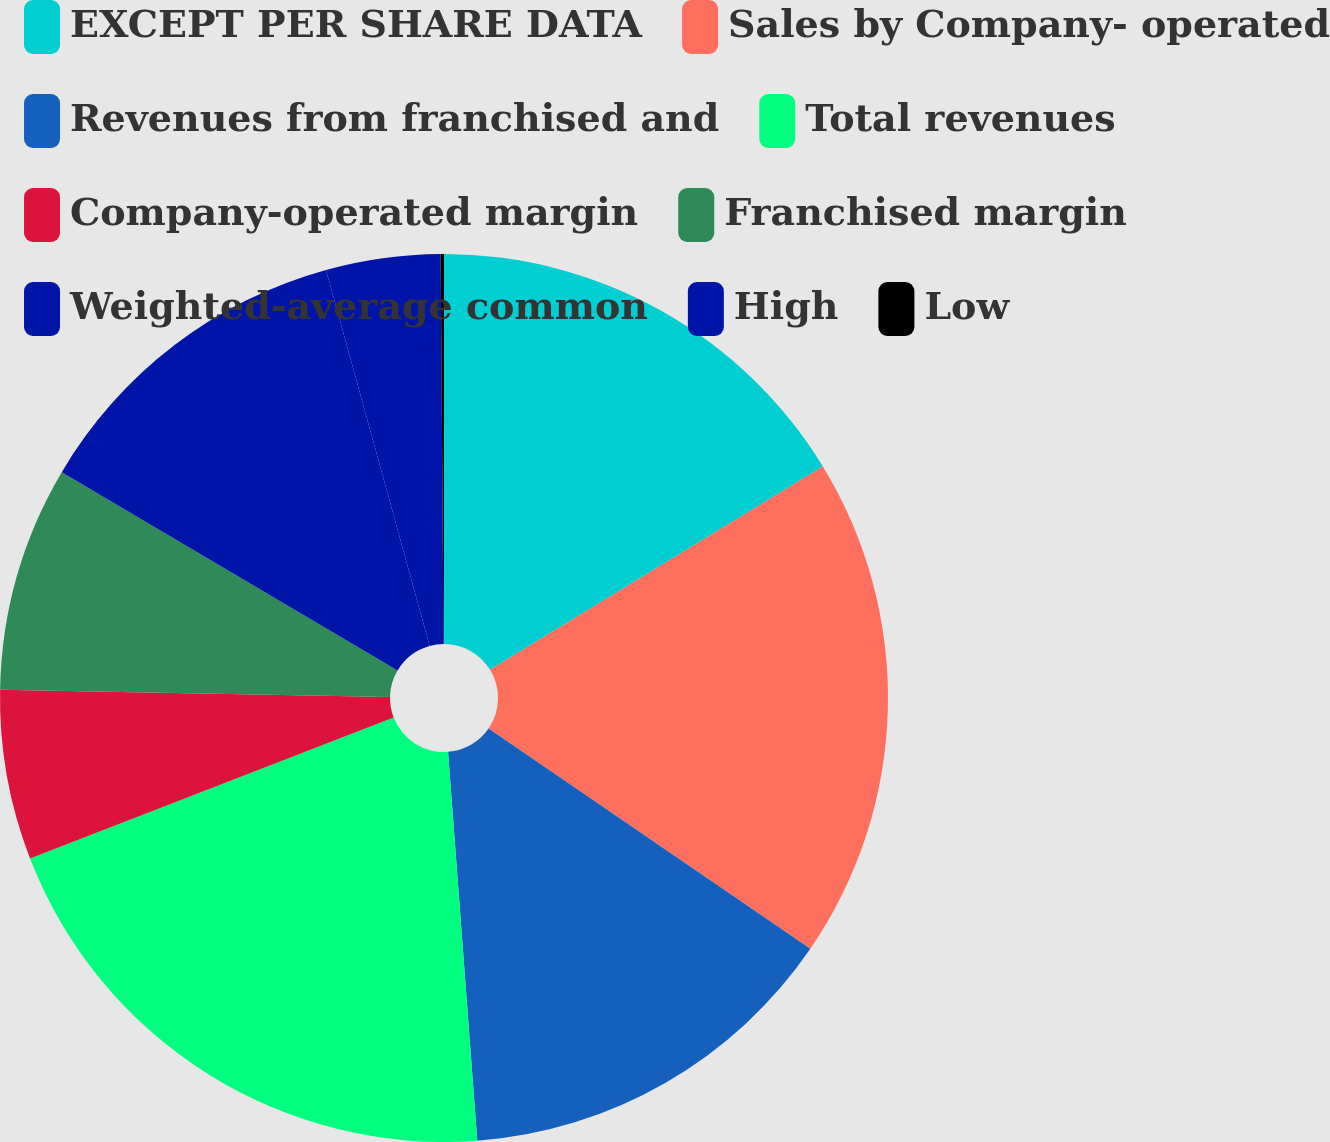Convert chart. <chart><loc_0><loc_0><loc_500><loc_500><pie_chart><fcel>EXCEPT PER SHARE DATA<fcel>Sales by Company- operated<fcel>Revenues from franchised and<fcel>Total revenues<fcel>Company-operated margin<fcel>Franchised margin<fcel>Weighted-average common<fcel>High<fcel>Low<nl><fcel>16.27%<fcel>18.29%<fcel>14.25%<fcel>20.31%<fcel>6.18%<fcel>8.2%<fcel>12.23%<fcel>4.16%<fcel>0.12%<nl></chart> 